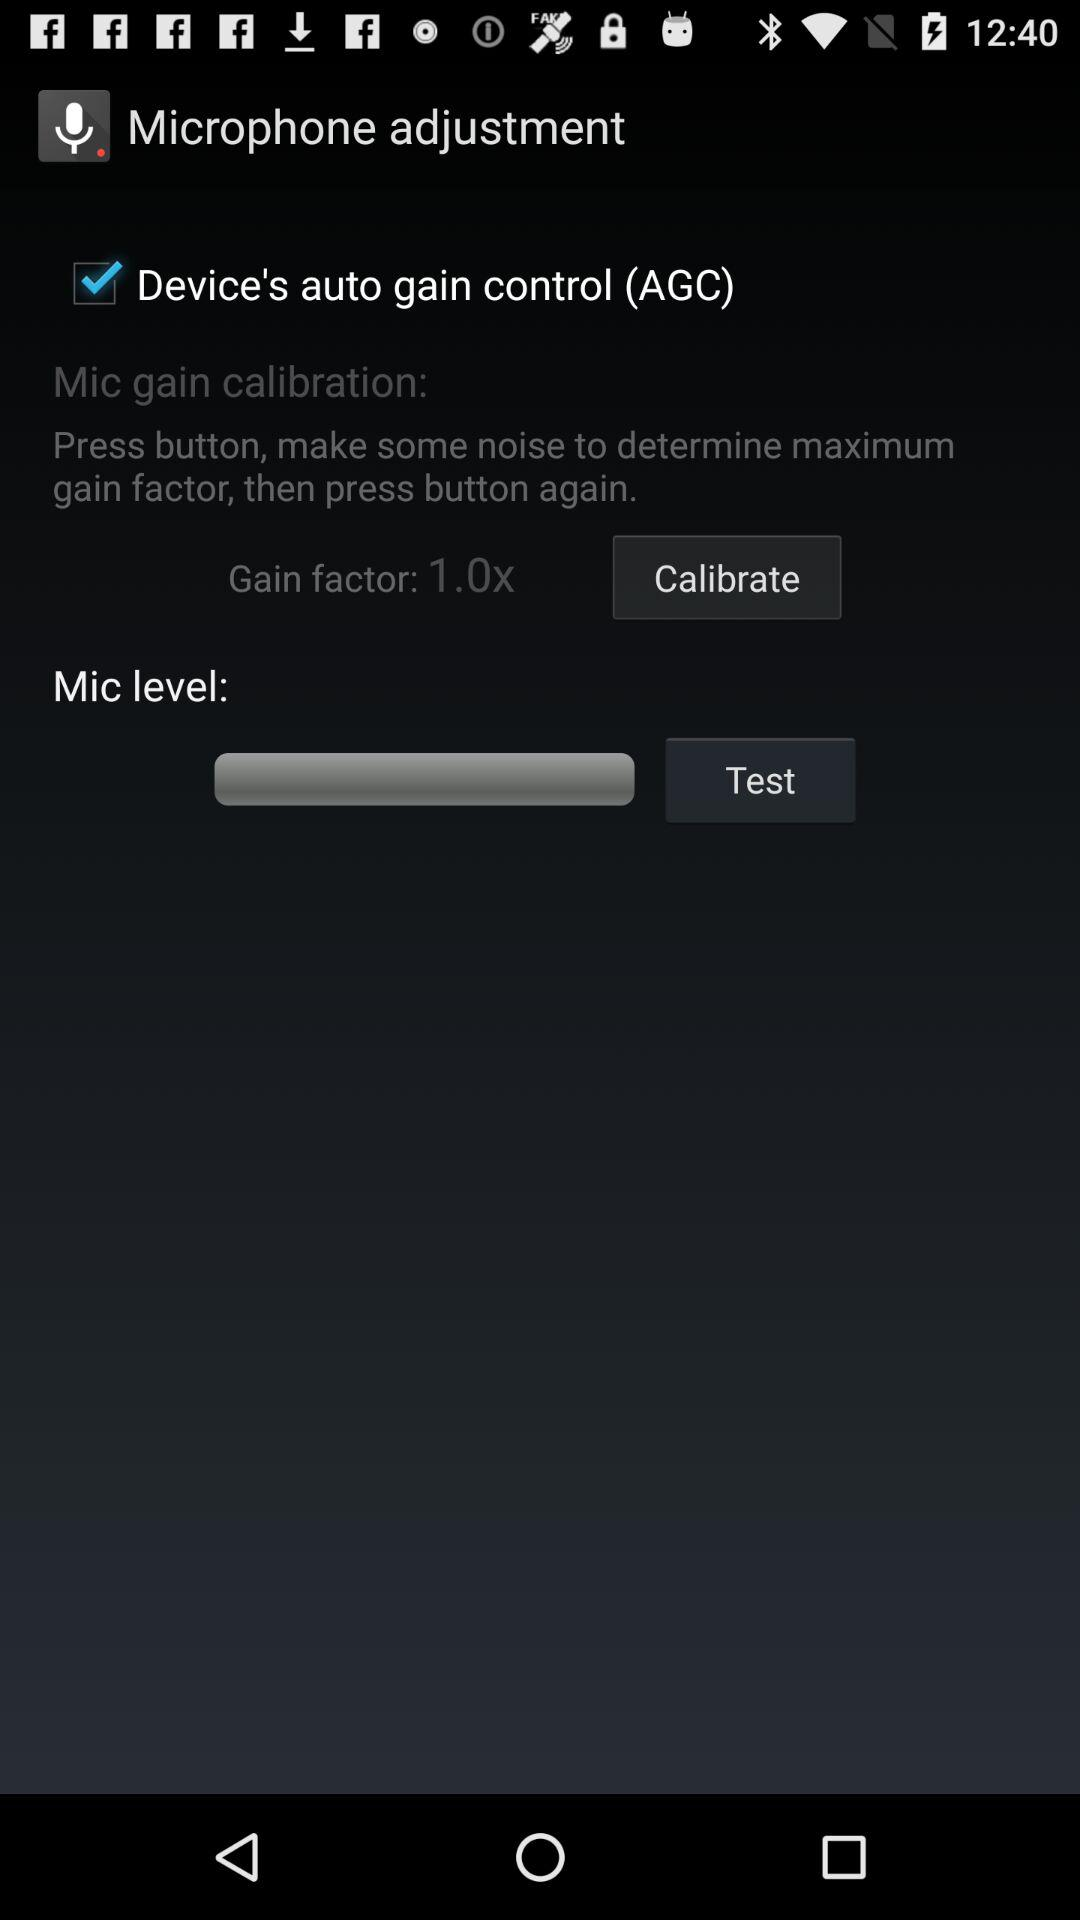What is the status of "Device's auto gain control (AGC)"? The status is "on". 